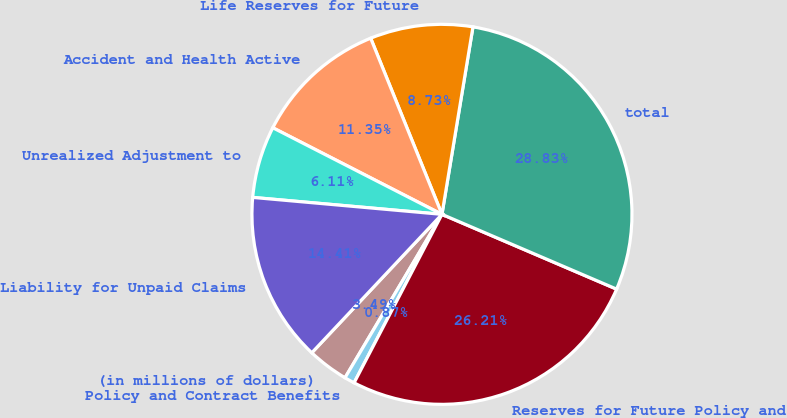Convert chart to OTSL. <chart><loc_0><loc_0><loc_500><loc_500><pie_chart><fcel>(in millions of dollars)<fcel>Policy and Contract Benefits<fcel>Reserves for Future Policy and<fcel>total<fcel>Life Reserves for Future<fcel>Accident and Health Active<fcel>Unrealized Adjustment to<fcel>Liability for Unpaid Claims<nl><fcel>3.49%<fcel>0.87%<fcel>26.21%<fcel>28.83%<fcel>8.73%<fcel>11.35%<fcel>6.11%<fcel>14.41%<nl></chart> 